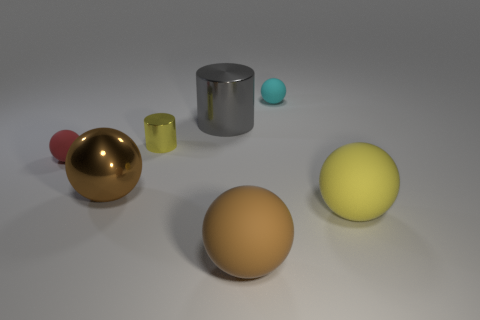Subtract all yellow matte spheres. How many spheres are left? 4 Subtract all red balls. How many balls are left? 4 Subtract all gray spheres. Subtract all brown cylinders. How many spheres are left? 5 Add 3 cyan balls. How many objects exist? 10 Subtract all cylinders. How many objects are left? 5 Add 2 yellow objects. How many yellow objects exist? 4 Subtract 1 gray cylinders. How many objects are left? 6 Subtract all yellow rubber blocks. Subtract all matte things. How many objects are left? 3 Add 3 yellow shiny cylinders. How many yellow shiny cylinders are left? 4 